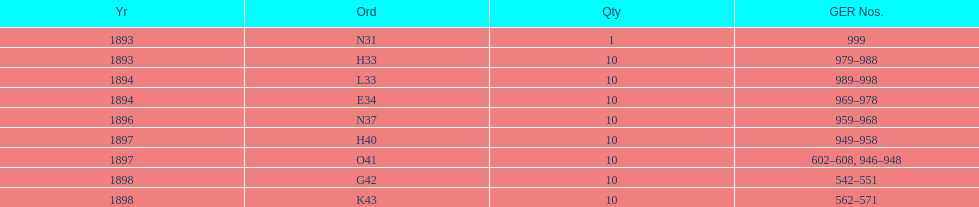What is the order of the last year listed? K43. 